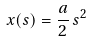<formula> <loc_0><loc_0><loc_500><loc_500>x ( s ) = \frac { a } { 2 } \, s ^ { 2 }</formula> 